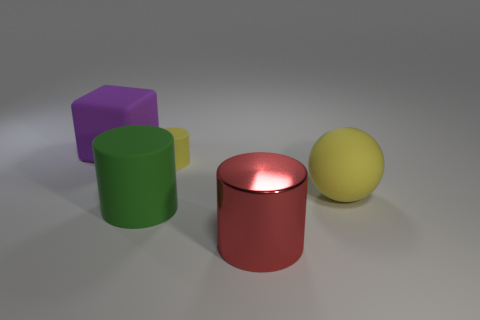Add 4 small cyan cylinders. How many objects exist? 9 Subtract all cylinders. How many objects are left? 2 Add 5 large matte blocks. How many large matte blocks are left? 6 Add 1 green cylinders. How many green cylinders exist? 2 Subtract 0 brown blocks. How many objects are left? 5 Subtract all tiny blue metallic cubes. Subtract all matte blocks. How many objects are left? 4 